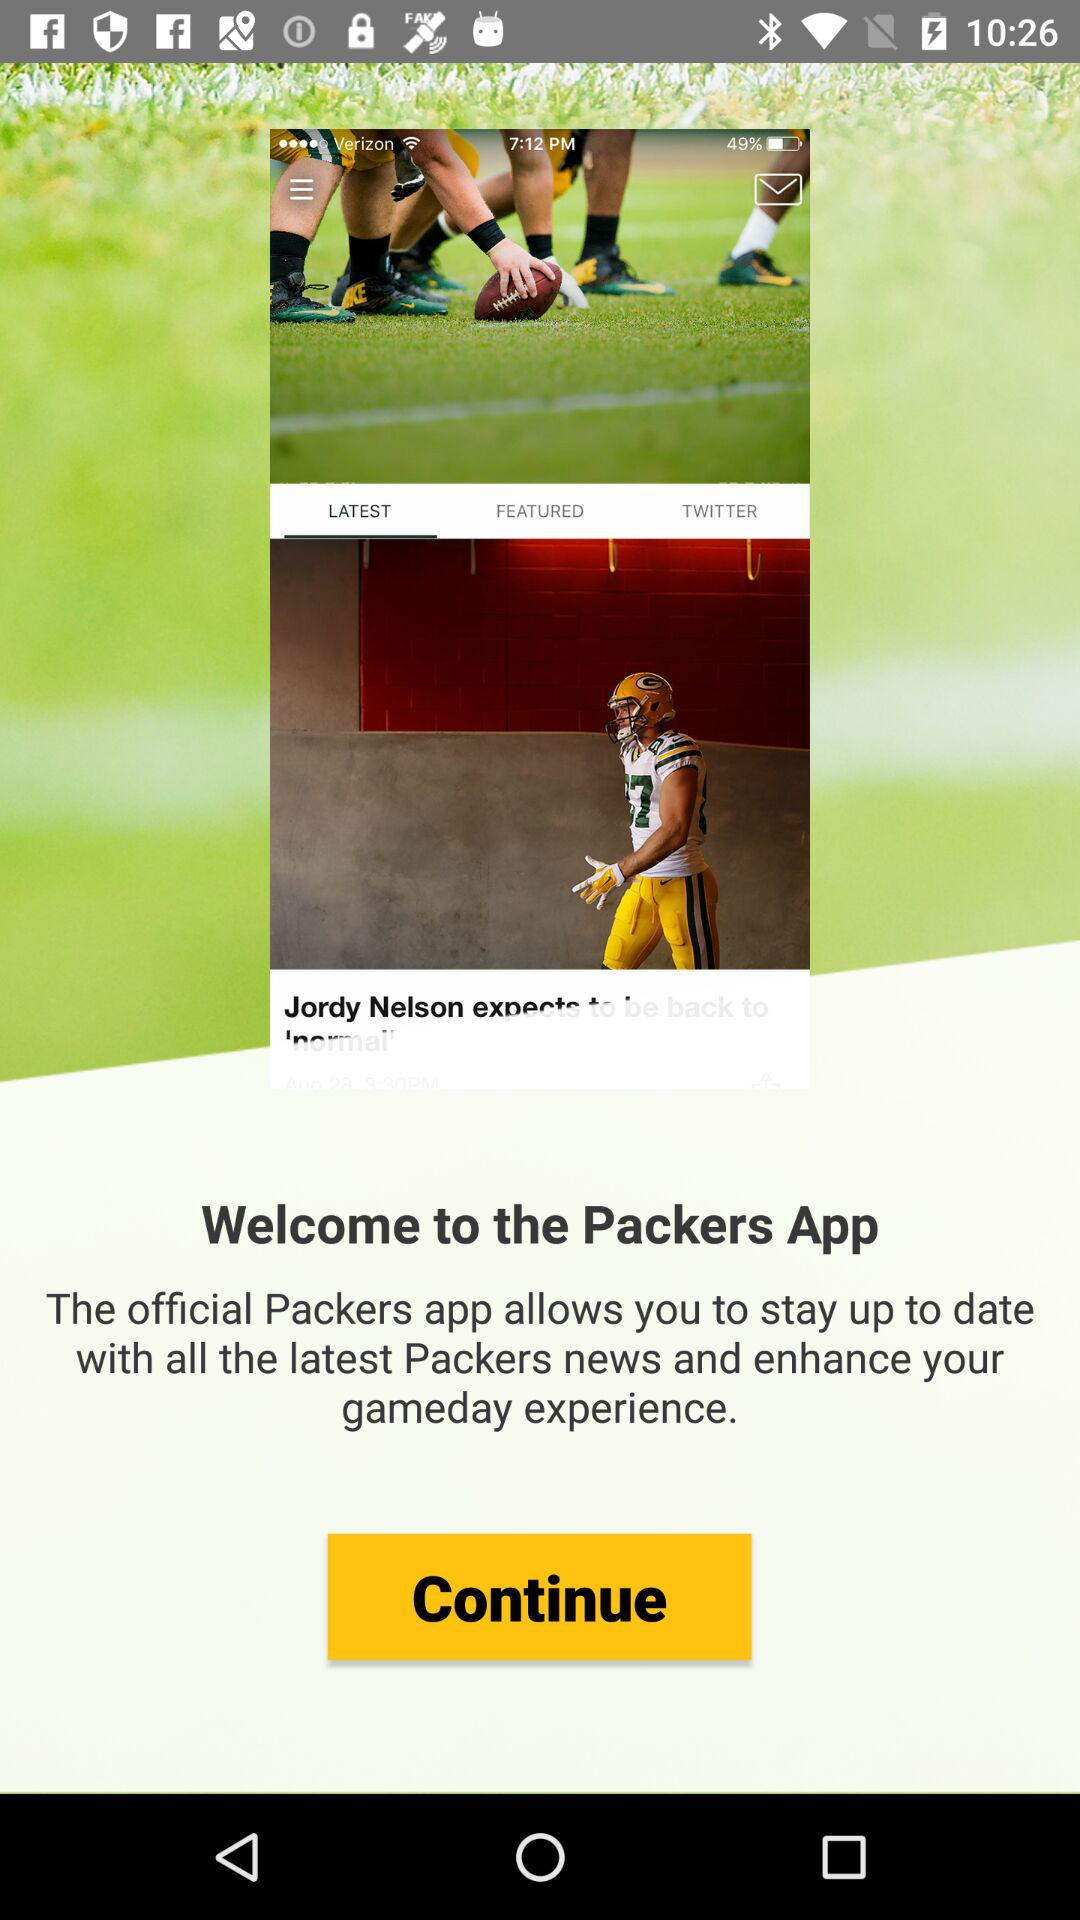What application is it? The application is "Packers App". 